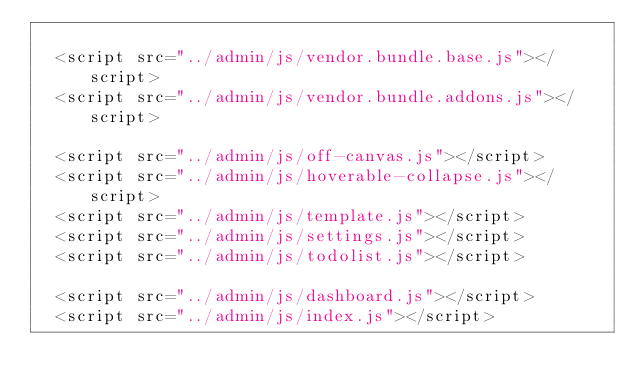<code> <loc_0><loc_0><loc_500><loc_500><_PHP_>
  <script src="../admin/js/vendor.bundle.base.js"></script>
  <script src="../admin/js/vendor.bundle.addons.js"></script>
  
  <script src="../admin/js/off-canvas.js"></script>
  <script src="../admin/js/hoverable-collapse.js"></script>
  <script src="../admin/js/template.js"></script>
  <script src="../admin/js/settings.js"></script>
  <script src="../admin/js/todolist.js"></script>
  
  <script src="../admin/js/dashboard.js"></script>
  <script src="../admin/js/index.js"></script>
  </code> 